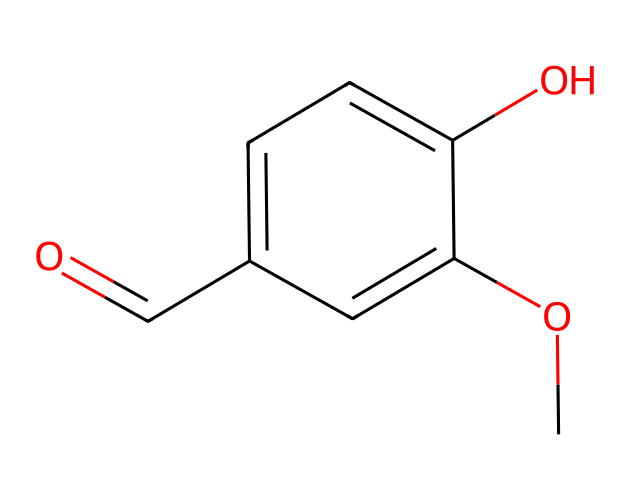What is the molecular formula of vanillin? By analyzing the SMILES representation, we identify the individual atoms: there are 8 carbons (C), 8 hydrogens (H), and 3 oxygens (O). Combining these gives the molecular formula C8H8O3.
Answer: C8H8O3 How many rings are present in the structure? The structure depicted does not contain any closed loops or cyclic compounds; it is a linear or open-chain structure. This means there are zero rings present.
Answer: 0 What functional group is present in vanillin? In the provided chemical structure, we see a carbonyl group (C=O) as well as a hydroxyl group (−OH) indicating the presence of an aldehyde and a phenolic group. The aldehyde is a key functional group in vanillin.
Answer: aldehyde How many double bonds are present in the chemical structure? From the SMILES notation, the carbonyl (C=O) indicates one double bond, while there are no other double bonds shown between carbon atoms. Therefore, there is only one double bond in total.
Answer: 1 Is vanillin a phenolic compound? The chemical structure includes a hydroxyl group (-OH) attached to a carbon ring, which indicates that vanillin is indeed classified as a phenolic compound.
Answer: yes What is the role of the aldehyde group in vanillin's flavor profile? The aldehyde group is key to the flavor and aroma properties of vanillin, as aldehydes generally contribute to sweet and floral scents, enhancing the overall flavor.
Answer: flavor contributor 